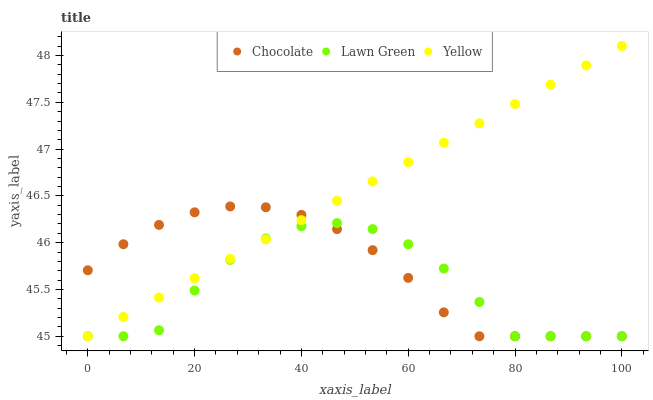Does Lawn Green have the minimum area under the curve?
Answer yes or no. Yes. Does Yellow have the maximum area under the curve?
Answer yes or no. Yes. Does Chocolate have the minimum area under the curve?
Answer yes or no. No. Does Chocolate have the maximum area under the curve?
Answer yes or no. No. Is Yellow the smoothest?
Answer yes or no. Yes. Is Lawn Green the roughest?
Answer yes or no. Yes. Is Chocolate the smoothest?
Answer yes or no. No. Is Chocolate the roughest?
Answer yes or no. No. Does Lawn Green have the lowest value?
Answer yes or no. Yes. Does Yellow have the highest value?
Answer yes or no. Yes. Does Chocolate have the highest value?
Answer yes or no. No. Does Yellow intersect Chocolate?
Answer yes or no. Yes. Is Yellow less than Chocolate?
Answer yes or no. No. Is Yellow greater than Chocolate?
Answer yes or no. No. 